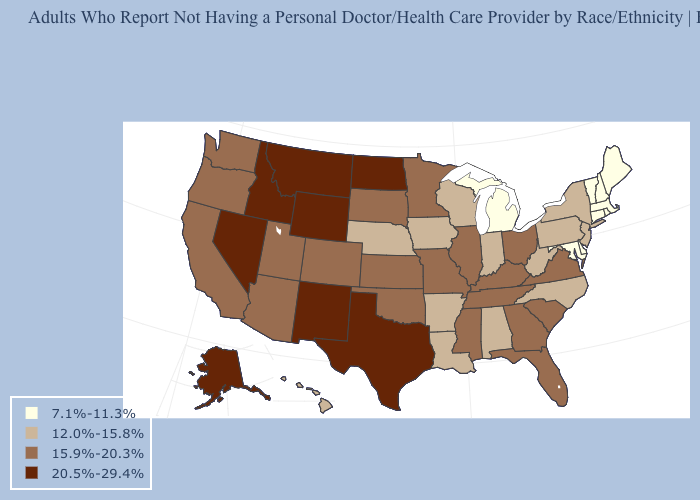Among the states that border Massachusetts , which have the lowest value?
Short answer required. Connecticut, New Hampshire, Rhode Island, Vermont. Does Alaska have the highest value in the West?
Quick response, please. Yes. Among the states that border Connecticut , does New York have the highest value?
Keep it brief. Yes. What is the lowest value in the USA?
Keep it brief. 7.1%-11.3%. Among the states that border Illinois , which have the lowest value?
Be succinct. Indiana, Iowa, Wisconsin. What is the lowest value in states that border Colorado?
Answer briefly. 12.0%-15.8%. How many symbols are there in the legend?
Answer briefly. 4. What is the value of Kentucky?
Keep it brief. 15.9%-20.3%. Which states have the lowest value in the USA?
Be succinct. Connecticut, Delaware, Maine, Maryland, Massachusetts, Michigan, New Hampshire, Rhode Island, Vermont. Does Nevada have a higher value than Wisconsin?
Write a very short answer. Yes. What is the highest value in states that border Oklahoma?
Answer briefly. 20.5%-29.4%. Does Alaska have the lowest value in the West?
Concise answer only. No. Does Vermont have a lower value than Wisconsin?
Concise answer only. Yes. Does the map have missing data?
Quick response, please. No. Name the states that have a value in the range 7.1%-11.3%?
Be succinct. Connecticut, Delaware, Maine, Maryland, Massachusetts, Michigan, New Hampshire, Rhode Island, Vermont. 